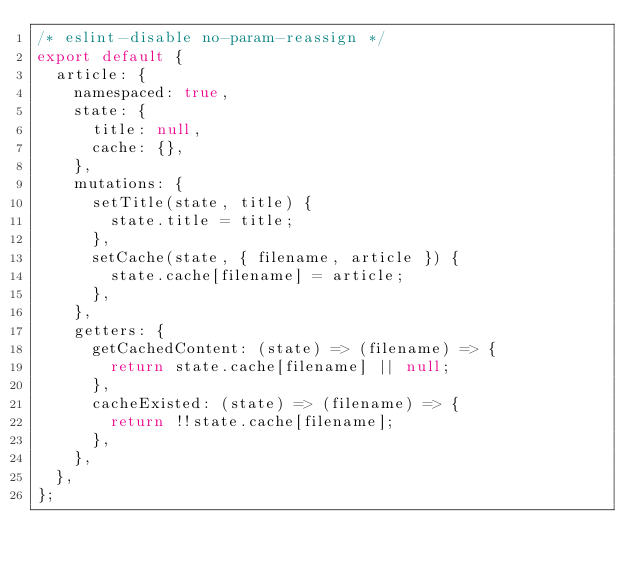Convert code to text. <code><loc_0><loc_0><loc_500><loc_500><_JavaScript_>/* eslint-disable no-param-reassign */
export default {
  article: {
    namespaced: true,
    state: {
      title: null,
      cache: {},
    },
    mutations: {
      setTitle(state, title) {
        state.title = title;
      },
      setCache(state, { filename, article }) {
        state.cache[filename] = article;
      },
    },
    getters: {
      getCachedContent: (state) => (filename) => {
        return state.cache[filename] || null;
      },
      cacheExisted: (state) => (filename) => {
        return !!state.cache[filename];
      },
    },
  },
};
</code> 